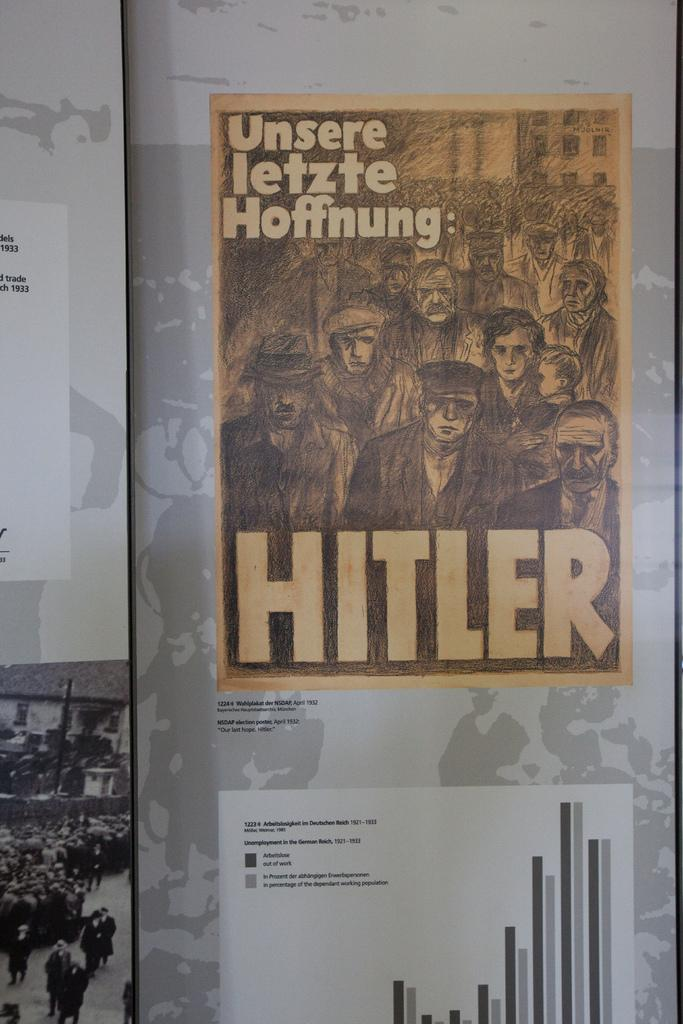<image>
Describe the image concisely. A poster with pictures of people and the name Hitler underneath. 